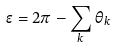Convert formula to latex. <formula><loc_0><loc_0><loc_500><loc_500>\epsilon = 2 \pi - \sum _ { k } \theta _ { k }</formula> 